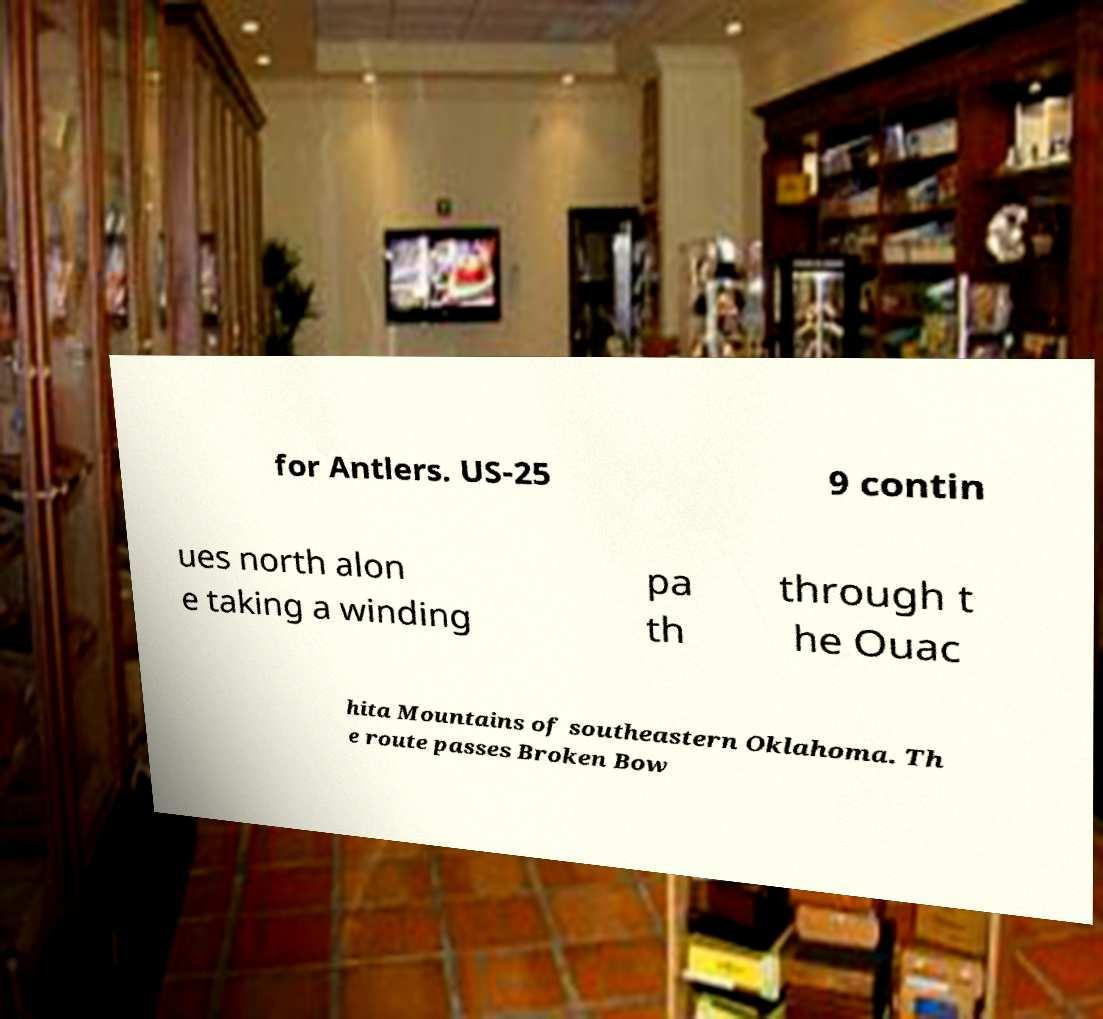For documentation purposes, I need the text within this image transcribed. Could you provide that? for Antlers. US-25 9 contin ues north alon e taking a winding pa th through t he Ouac hita Mountains of southeastern Oklahoma. Th e route passes Broken Bow 